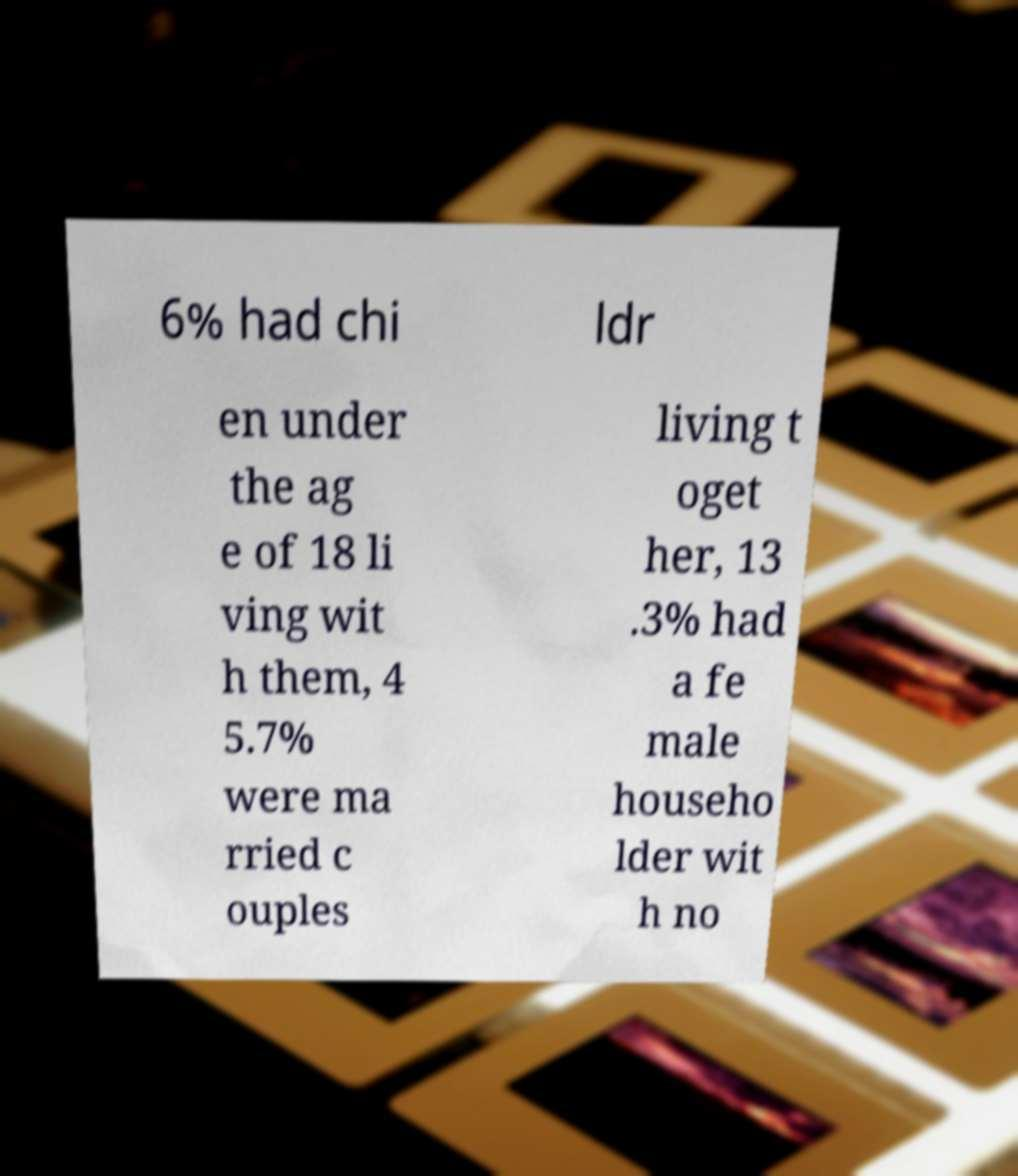Please read and relay the text visible in this image. What does it say? 6% had chi ldr en under the ag e of 18 li ving wit h them, 4 5.7% were ma rried c ouples living t oget her, 13 .3% had a fe male househo lder wit h no 